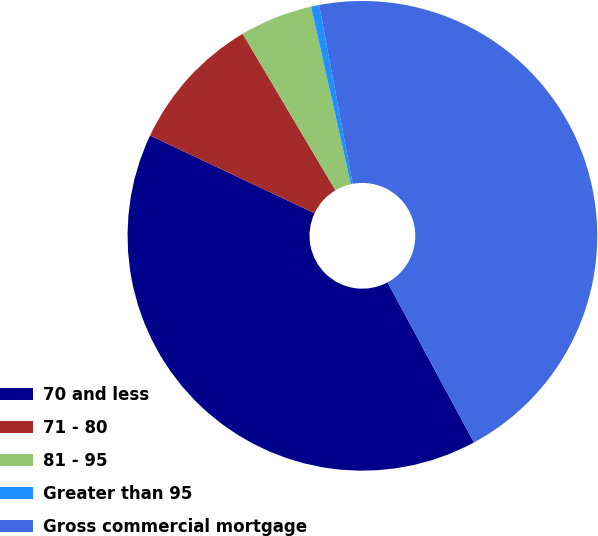<chart> <loc_0><loc_0><loc_500><loc_500><pie_chart><fcel>70 and less<fcel>71 - 80<fcel>81 - 95<fcel>Greater than 95<fcel>Gross commercial mortgage<nl><fcel>39.9%<fcel>9.46%<fcel>5.01%<fcel>0.56%<fcel>45.07%<nl></chart> 